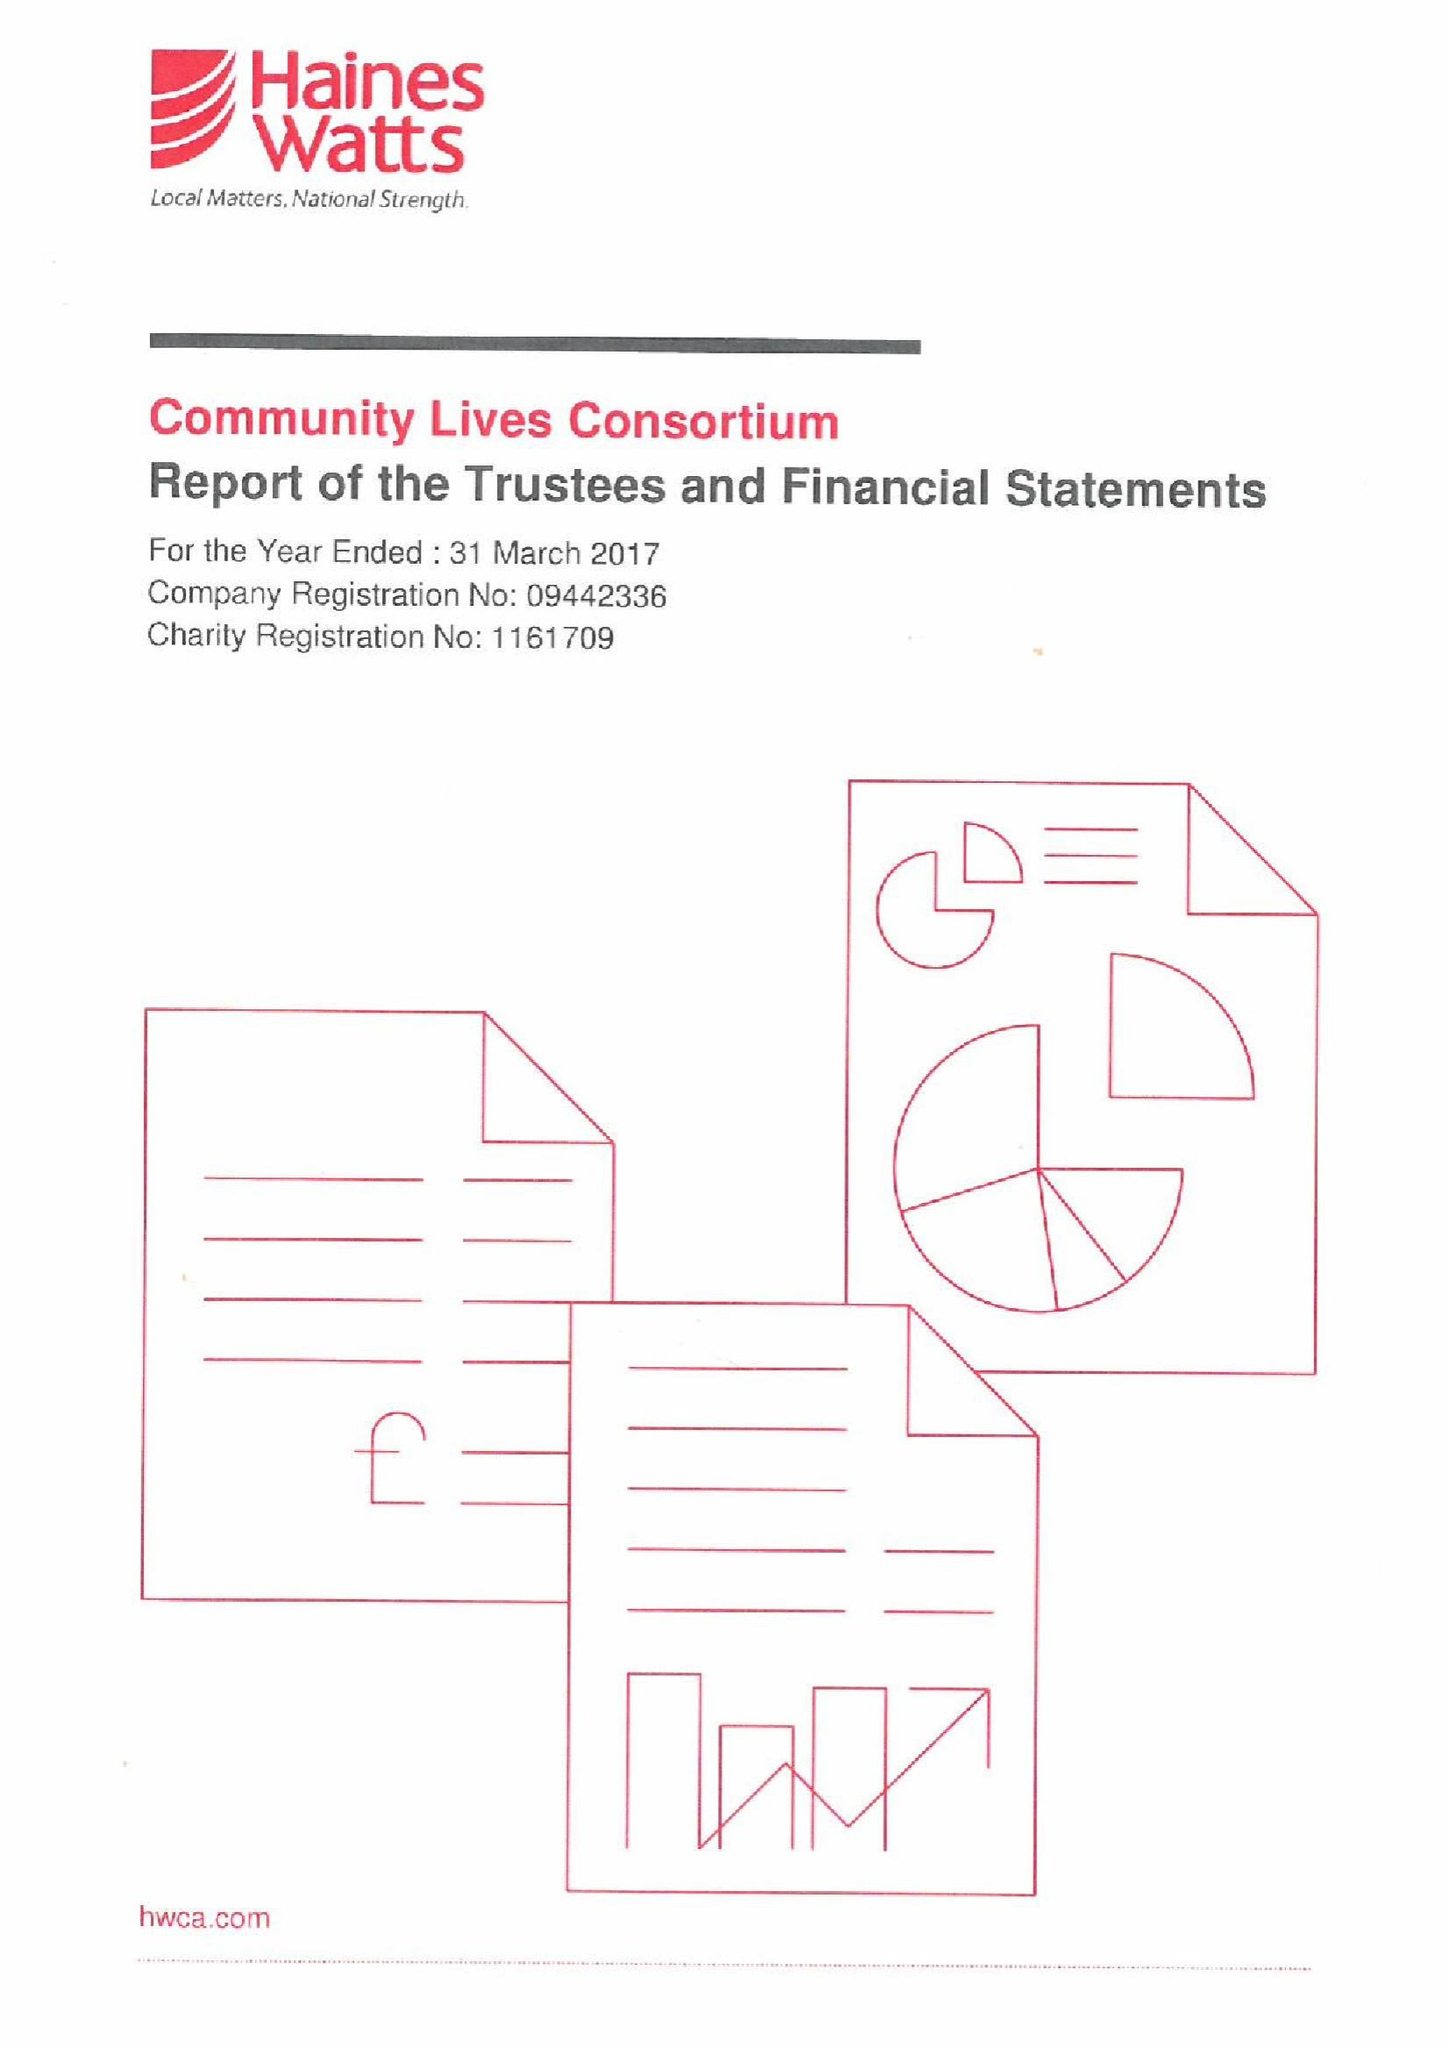What is the value for the income_annually_in_british_pounds?
Answer the question using a single word or phrase. 15845967.00 